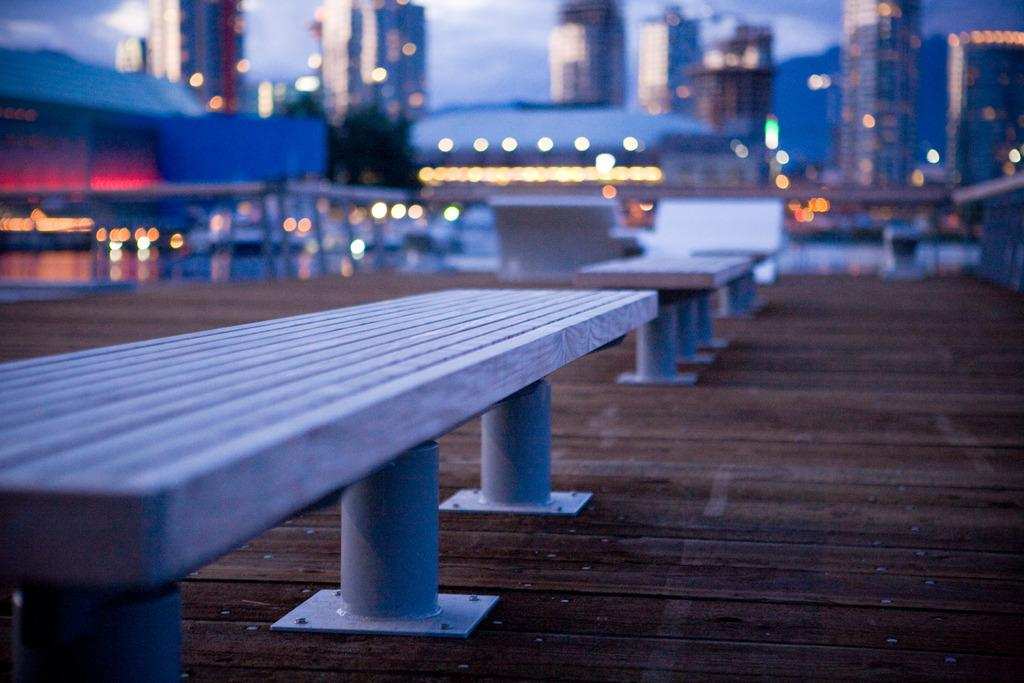What type of furniture is present on the wooden surface in the image? There are benches on a wooden surface in the image. What can be seen in the distance behind the wooden surface? There are many buildings and lights visible in the background of the image. What part of the natural environment is visible in the image? The sky is visible in the background of the image. How would you describe the appearance of the background in the image? The background appears blurred. What type of curtain is hanging in front of the buildings in the image? There is no curtain present in the image; the buildings and lights are visible in the background. 